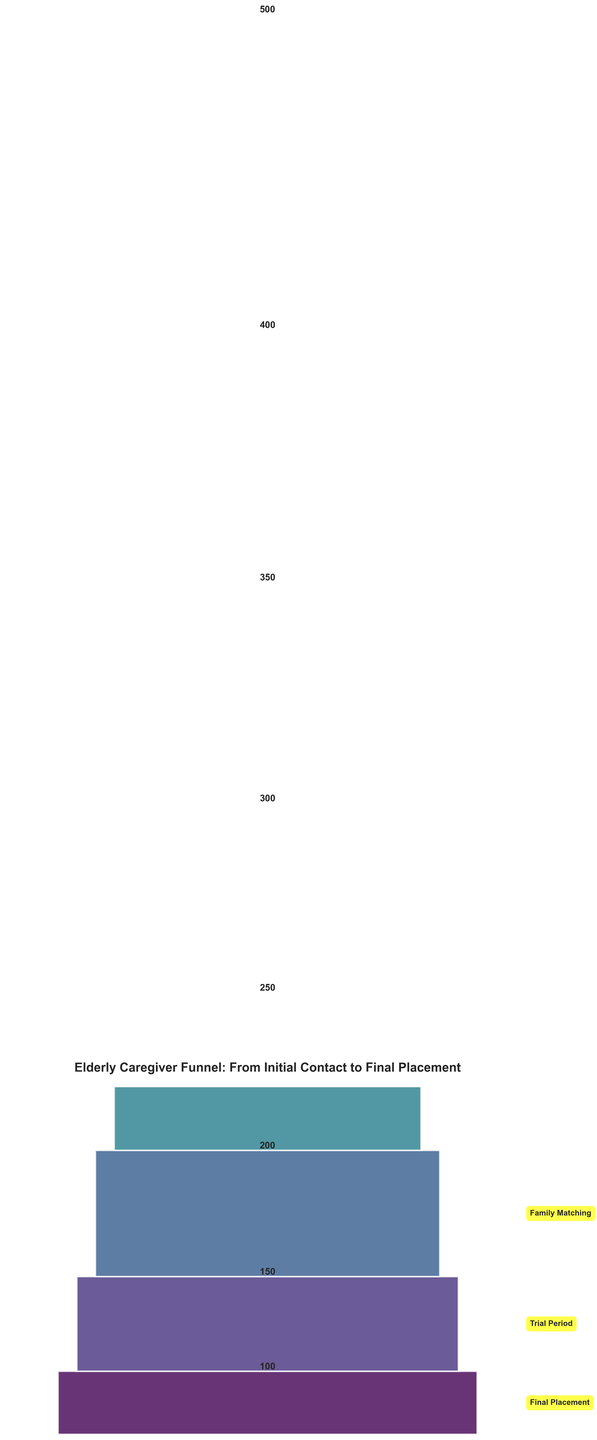What's the title of the funnel chart? The title is displayed at the top of the chart and summarizes what the chart is about. In this case, it's "Elderly Caregiver Funnel: From Initial Contact to Final Placement."
Answer: Elderly Caregiver Funnel: From Initial Contact to Final Placement How many stages are there in the funnel chart? The funnel chart shows segments corresponding to different stages. By counting these segments, we can determine the number of stages. There are 8 distinct stages labeled from top to bottom.
Answer: 8 Which stage has the highest number of elderly caregivers? By looking at the values associated with each stage, the stage with the highest value represents the most caregivers. The widest bar at the top shows the "Initial Contact" stage with 500 caregivers.
Answer: Initial Contact How many elderly caregivers were lost between the Health Assessment and Skills Evaluation stages? To find the difference between these stages, we look at their values and perform a subtraction: 300 (Health Assessment) - 250 (Skills Evaluation).
Answer: 50 What is the difference in the number of elderly caregivers from the initial contact stage to the final placement stage? Subtract the number of caregivers at the final stage from the initial stage: 500 (Initial Contact) - 100 (Final Placement).
Answer: 400 Which stage experienced the highest drop in the number of elderly caregivers? Calculate the drop between consecutive stages: 500-400=100, 400-350=50, 350-300=50, 300-250=50, 250-200=50, 200-150=50, 150-100=50. The largest drop is between "Initial Contact" and "Preliminary Screening".
Answer: Initial Contact to Preliminary Screening What is the average number of elderly caregivers across all stages? Calculate the sum of all the values and divide by the number of stages: (500 + 400 + 350 + 300 + 250 + 200 + 150 + 100)/8.
Answer: 281.25 Between which stages do we see an equal drop in the number of elderly caregivers? To find equal drops, compare the differences between stages: 500-400=100, 400-350=50, 350-300=50, 300-250=50, 250-200=50, 200-150=50, 150-100=50. The equal drops are between Preliminary Screening and Background Check, followed by all subsequent stages.
Answer: Preliminary Screening to Background Check and all subsequent stages Is there any stage where the number of elderly caregivers remains unchanged from the previous stage? Check for any two consecutive stages with the same number of caregivers. Since the queried chart shows declines in each stage, there are no stages with unchanged numbers.
Answer: No How many caregivers moved from the Family Matching stage to the Trial Period stage? Look at the values for the Family Matching and Trial Period stages: 200 (Family Matching) - 150 (Trial Period).
Answer: 50 